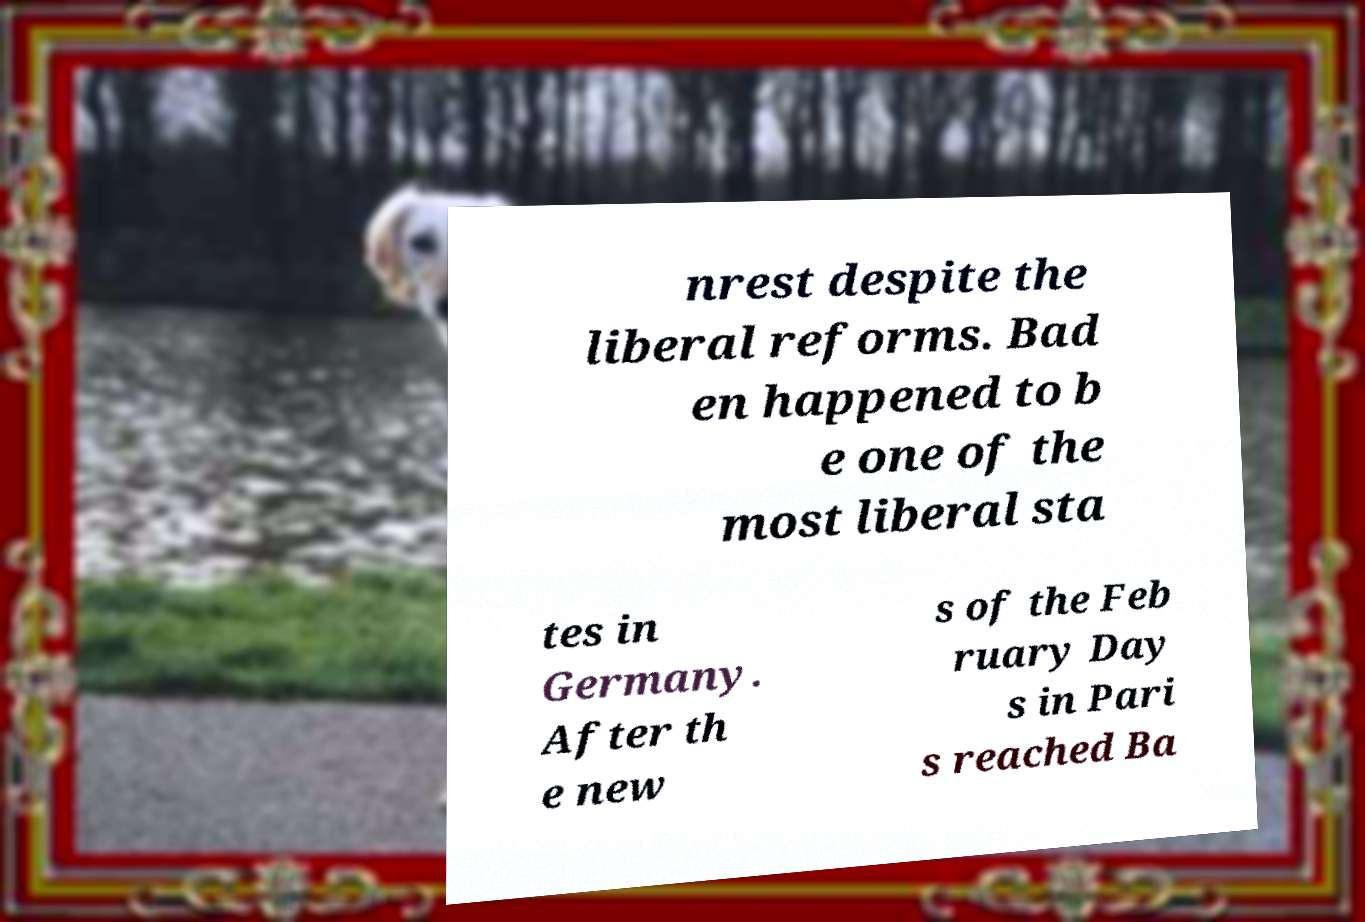Could you assist in decoding the text presented in this image and type it out clearly? nrest despite the liberal reforms. Bad en happened to b e one of the most liberal sta tes in Germany. After th e new s of the Feb ruary Day s in Pari s reached Ba 